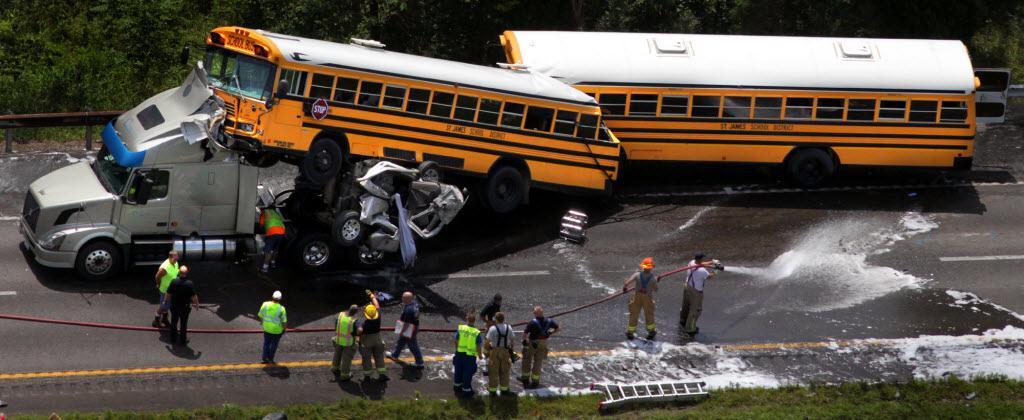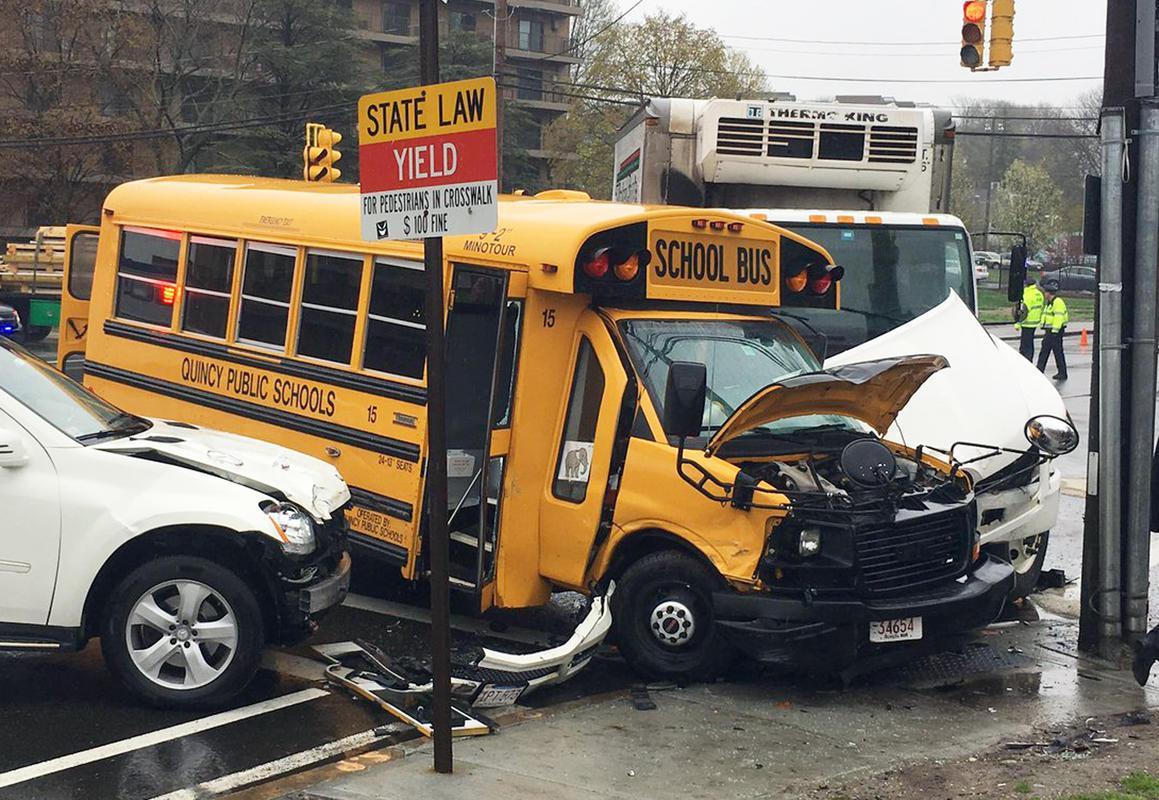The first image is the image on the left, the second image is the image on the right. Considering the images on both sides, is "Exactly one bus is on a truck." valid? Answer yes or no. Yes. 